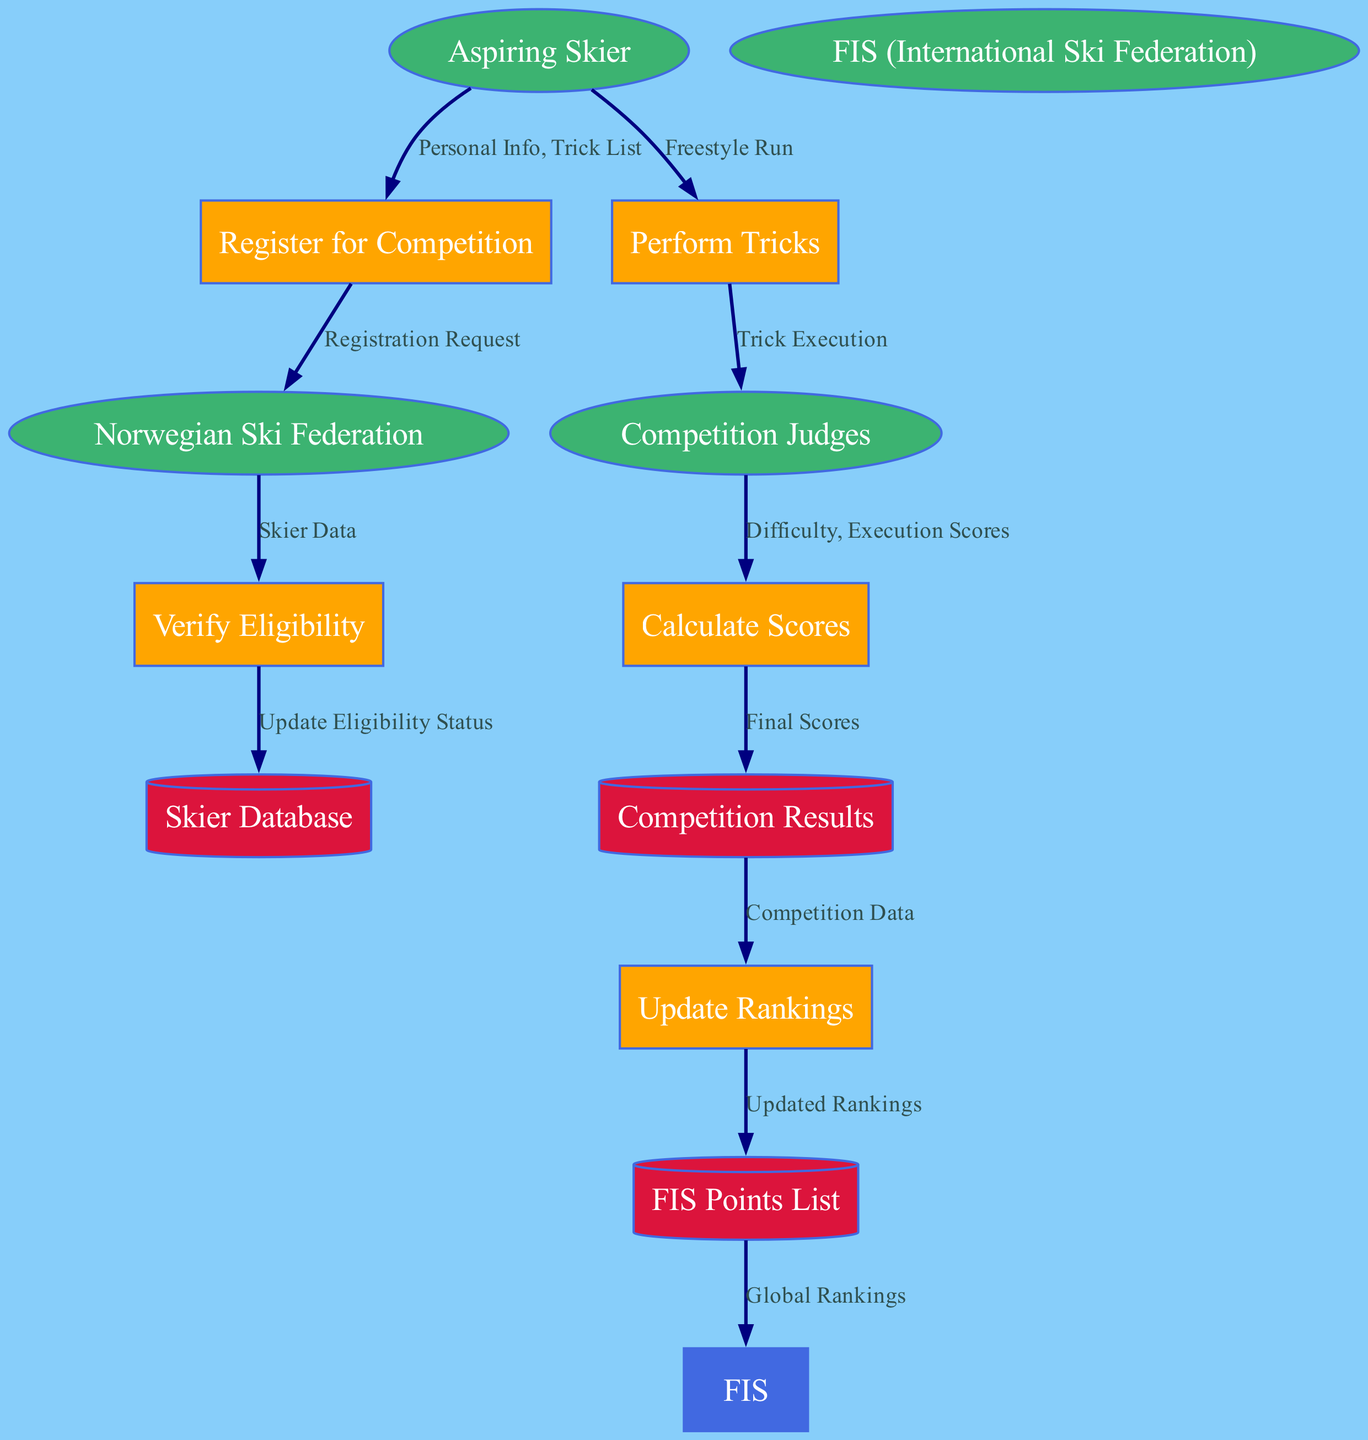What is the primary external entity involved in registration? The diagram indicates "Aspiring Skier" as the primary external entity that initiates the registration process by providing personal information and a trick list.
Answer: Aspiring Skier How many processes are present in the diagram? By counting the blocks labeled as processes, we see five distinct processes listed in the diagram that represent the functions within the competition registration and scoring system.
Answer: 5 Which entity sends a "Registration Request"? The "Register for Competition" process sends a "Registration Request" to the "Norwegian Ski Federation," indicating that the registration process involves this specific communication.
Answer: Norwegian Ski Federation What data is sent from "Competition Judges" to "Calculate Scores"? The "Competition Judges" provide "Difficulty" and "Execution Scores" to the "Calculate Scores" process, indicating what factors are considered in score calculation.
Answer: Difficulty, Execution Scores What stores the final scores generated during the competition? The final scores calculated during the competition are sent to the "Competition Results" data store, which acts as a repository for outcome-related data.
Answer: Competition Results What is the flow from "Update Rankings" to "FIS"? The "Update Rankings" process sends "Updated Rankings" to the "FIS," indicating that this flow represents how the rankings are communicated to the International Ski Federation.
Answer: Updated Rankings Where does "Skier Database" receive an update from? The "Skier Database" receives updates from the "Verify Eligibility" process, which ensures that skier eligibility status is maintained accurately within this database.
Answer: Verify Eligibility What is the function of the "Perform Tricks" process? The "Perform Tricks" process represents the skiers executing their freestyle runs, linking the athletes’ performance directly with the judges’ assessment during competition.
Answer: Execute Freestyle Run Which data store contains the global rankings? The global rankings are contained in the "FIS Points List," demonstrating the broader impact of individual competition results on the international skiing community.
Answer: FIS Points List 